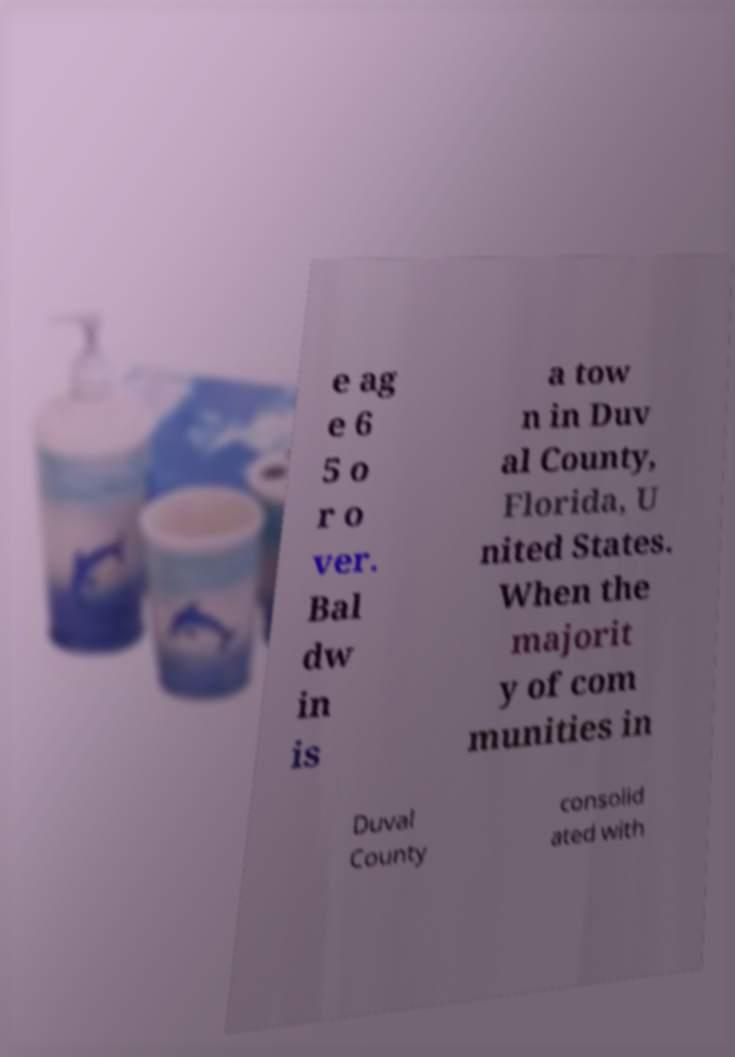What messages or text are displayed in this image? I need them in a readable, typed format. e ag e 6 5 o r o ver. Bal dw in is a tow n in Duv al County, Florida, U nited States. When the majorit y of com munities in Duval County consolid ated with 